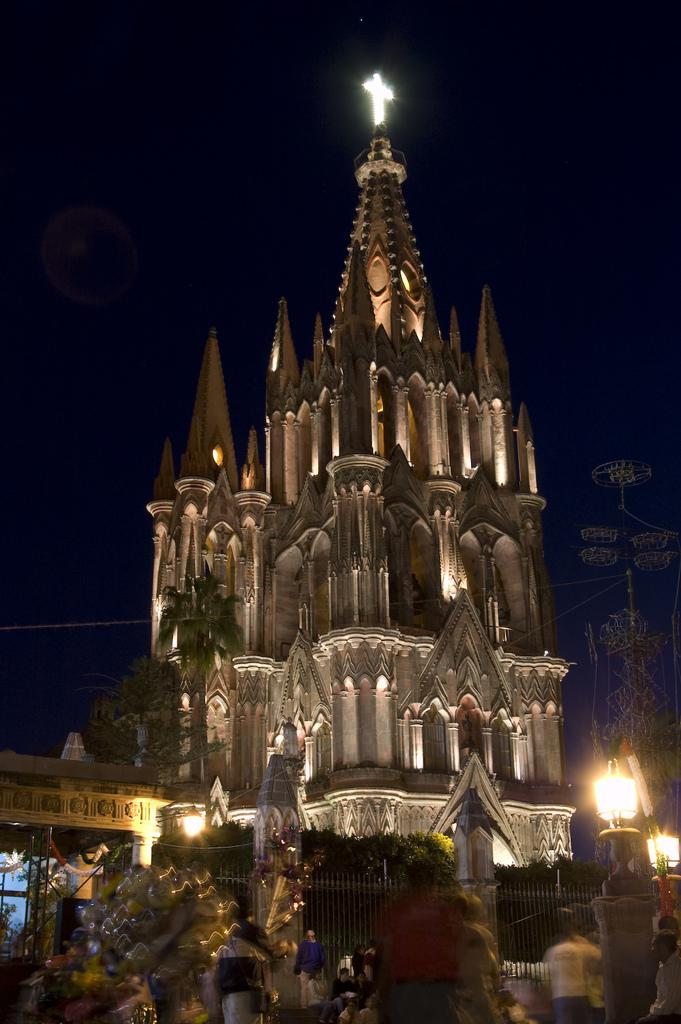What is the main structure in the center of the image? There is a tower in the center of the image. What type of natural elements can be seen in the image? There are trees visible in the image. What is located on the right side of the image? There is a pole on the right side of the image. What is attached to the pole? Lights are present on the pole. Who or what is at the bottom of the image? There are people at the bottom of the image. What type of salt can be seen on the board in the image? There is no salt or board present in the image. What color is the marble on the left side of the image? There is no marble present in the image. 